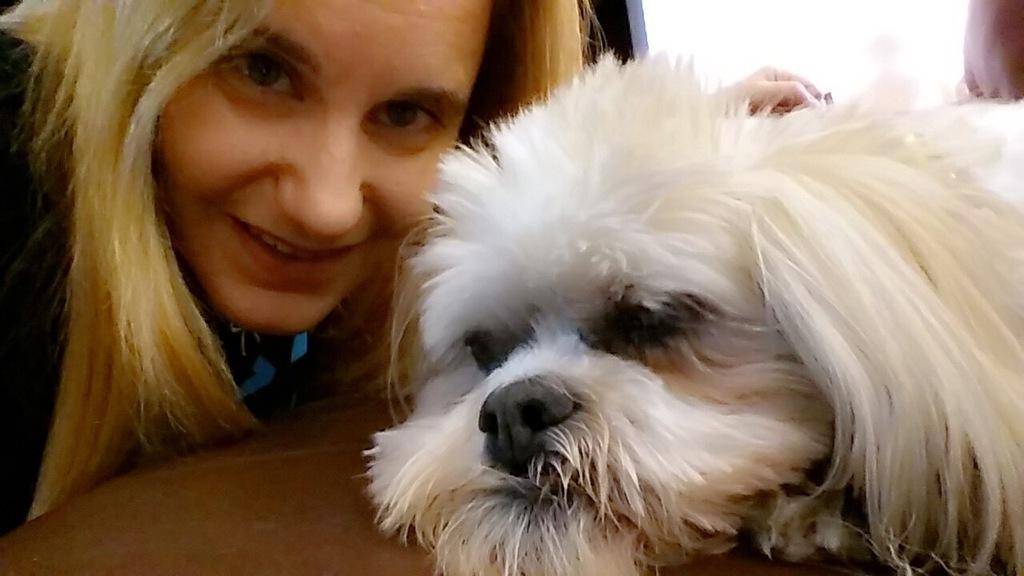Who is present in the image? There is a woman in the image. Where is the woman located in the image? The woman is on the left side of the image. What is the woman's expression in the image? The woman is smiling in the image. What other living creature is present in the image? There is a white dog in the image. Where is the dog located in the image? The dog is on the right side of the image. What ideas does the woman have about the upcoming competition in the image? There is no mention of a competition in the image, so it is not possible to determine the woman's ideas about any such event. 